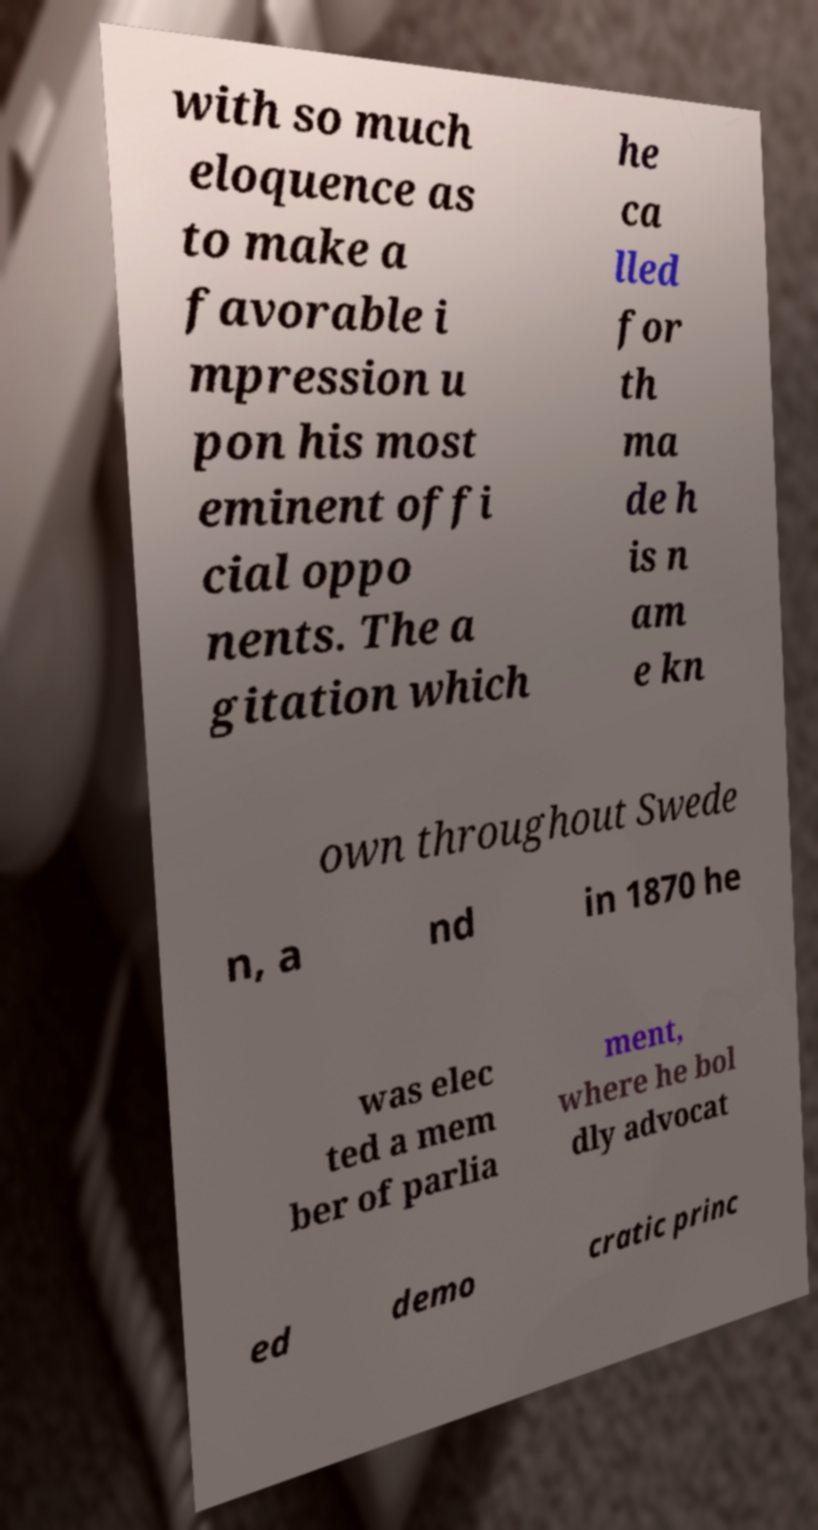There's text embedded in this image that I need extracted. Can you transcribe it verbatim? with so much eloquence as to make a favorable i mpression u pon his most eminent offi cial oppo nents. The a gitation which he ca lled for th ma de h is n am e kn own throughout Swede n, a nd in 1870 he was elec ted a mem ber of parlia ment, where he bol dly advocat ed demo cratic princ 